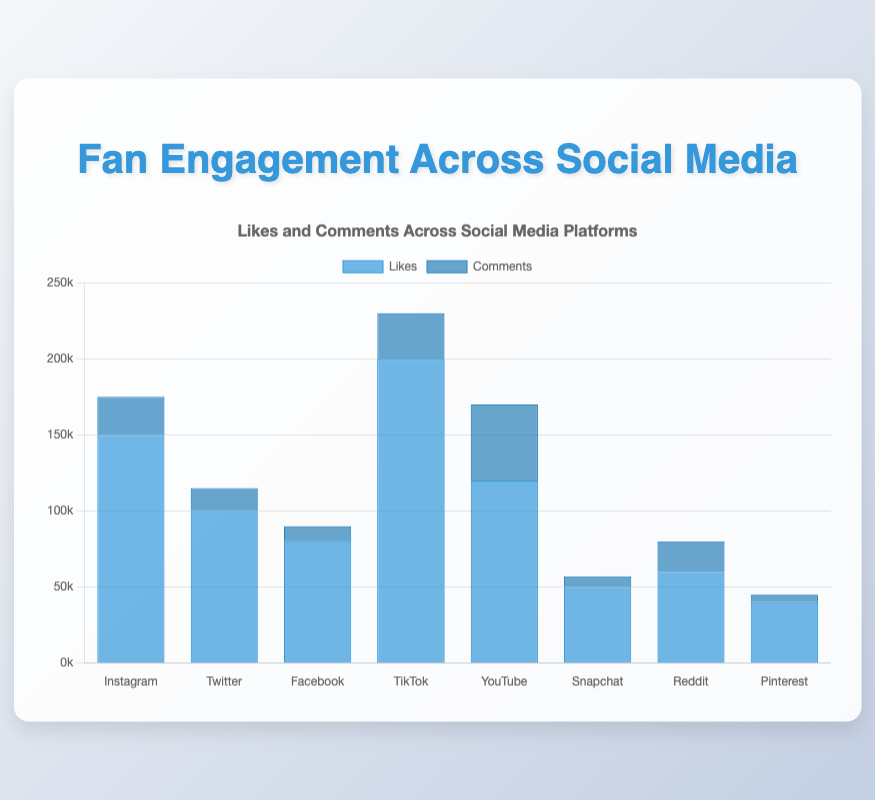Which platform has the highest number of likes? By looking at the height of the 'Likes' bars, TikTok has the highest bar, indicating the most likes.
Answer: TikTok Which platform receives the most comments? From the height of the 'Comments' bars, YouTube has the highest bar, indicating the most comments.
Answer: YouTube How many more likes does Instagram have compared to Snapchat? Instagram has 150,000 likes, and Snapchat has 50,000 likes. The difference is calculated as 150,000 - 50,000.
Answer: 100,000 Which platform has the least engagement in terms of comments? By identifying the shortest 'Comments' bar, Pinterest has the least engagement with 5,000 comments.
Answer: Pinterest What is the combined total of likes for Twitter and Reddit? Twitter has 100,000 likes and Reddit has 60,000 likes. Summing them results in 100,000 + 60,000.
Answer: 160,000 Which platform has more comments, Facebook or Instagram? Comparing the height of the 'Comments' bars, Instagram has 25,000 comments, and Facebook has 10,000. Therefore, Instagram has more comments.
Answer: Instagram What is the ratio of likes to comments on YouTube? YouTube has 120,000 likes and 50,000 comments. The ratio is found by dividing likes by comments: 120,000 / 50,000.
Answer: 2.4 Which platform has a higher total engagement (sum of likes and comments), TikTok or Twitter? TikTok has 200,000 likes and 30,000 comments. Twitter has 100,000 likes and 15,000 comments. Summing the engagements gives TikTok: 230,000 and Twitter: 115,000.
Answer: TikTok What is the average number of comments across all platforms? Adding all comments: 25k (Instagram) + 15k (Twitter) + 10k (Facebook) + 30k (TikTok) + 50k (YouTube) + 7k (Snapchat) + 20k (Reddit) + 5k (Pinterest) gives 162k. There are 8 platforms, so 162,000 / 8.
Answer: 20,250 